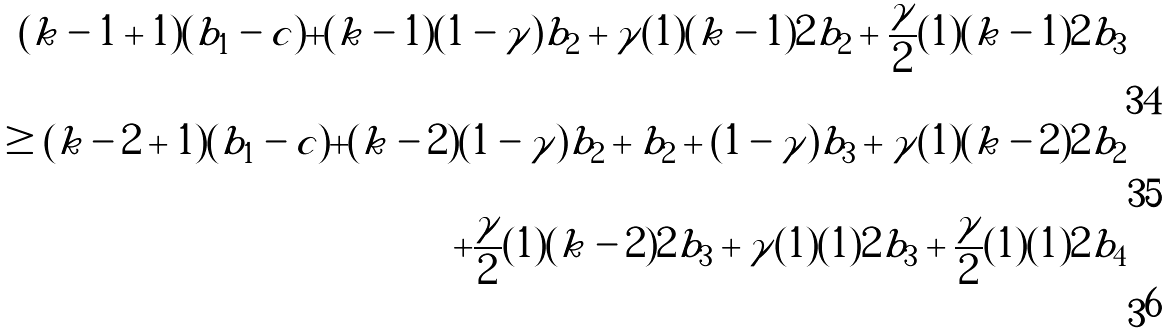<formula> <loc_0><loc_0><loc_500><loc_500>( k - 1 + 1 ) ( b _ { 1 } - c ) + ( k - 1 ) ( 1 - \gamma ) b _ { 2 } + \gamma ( 1 ) ( k - 1 ) 2 b _ { 2 } + \frac { \gamma } { 2 } ( 1 ) ( k - 1 ) 2 b _ { 3 } \\ \geq ( k - 2 + 1 ) ( b _ { 1 } - c ) + ( k - 2 ) ( 1 - \gamma ) b _ { 2 } + b _ { 2 } + ( 1 - \gamma ) b _ { 3 } + \gamma ( 1 ) ( k - 2 ) 2 b _ { 2 } \\ + \frac { \gamma } { 2 } ( 1 ) ( k - 2 ) 2 b _ { 3 } + \gamma ( 1 ) ( 1 ) 2 b _ { 3 } + \frac { \gamma } { 2 } ( 1 ) ( 1 ) 2 b _ { 4 }</formula> 